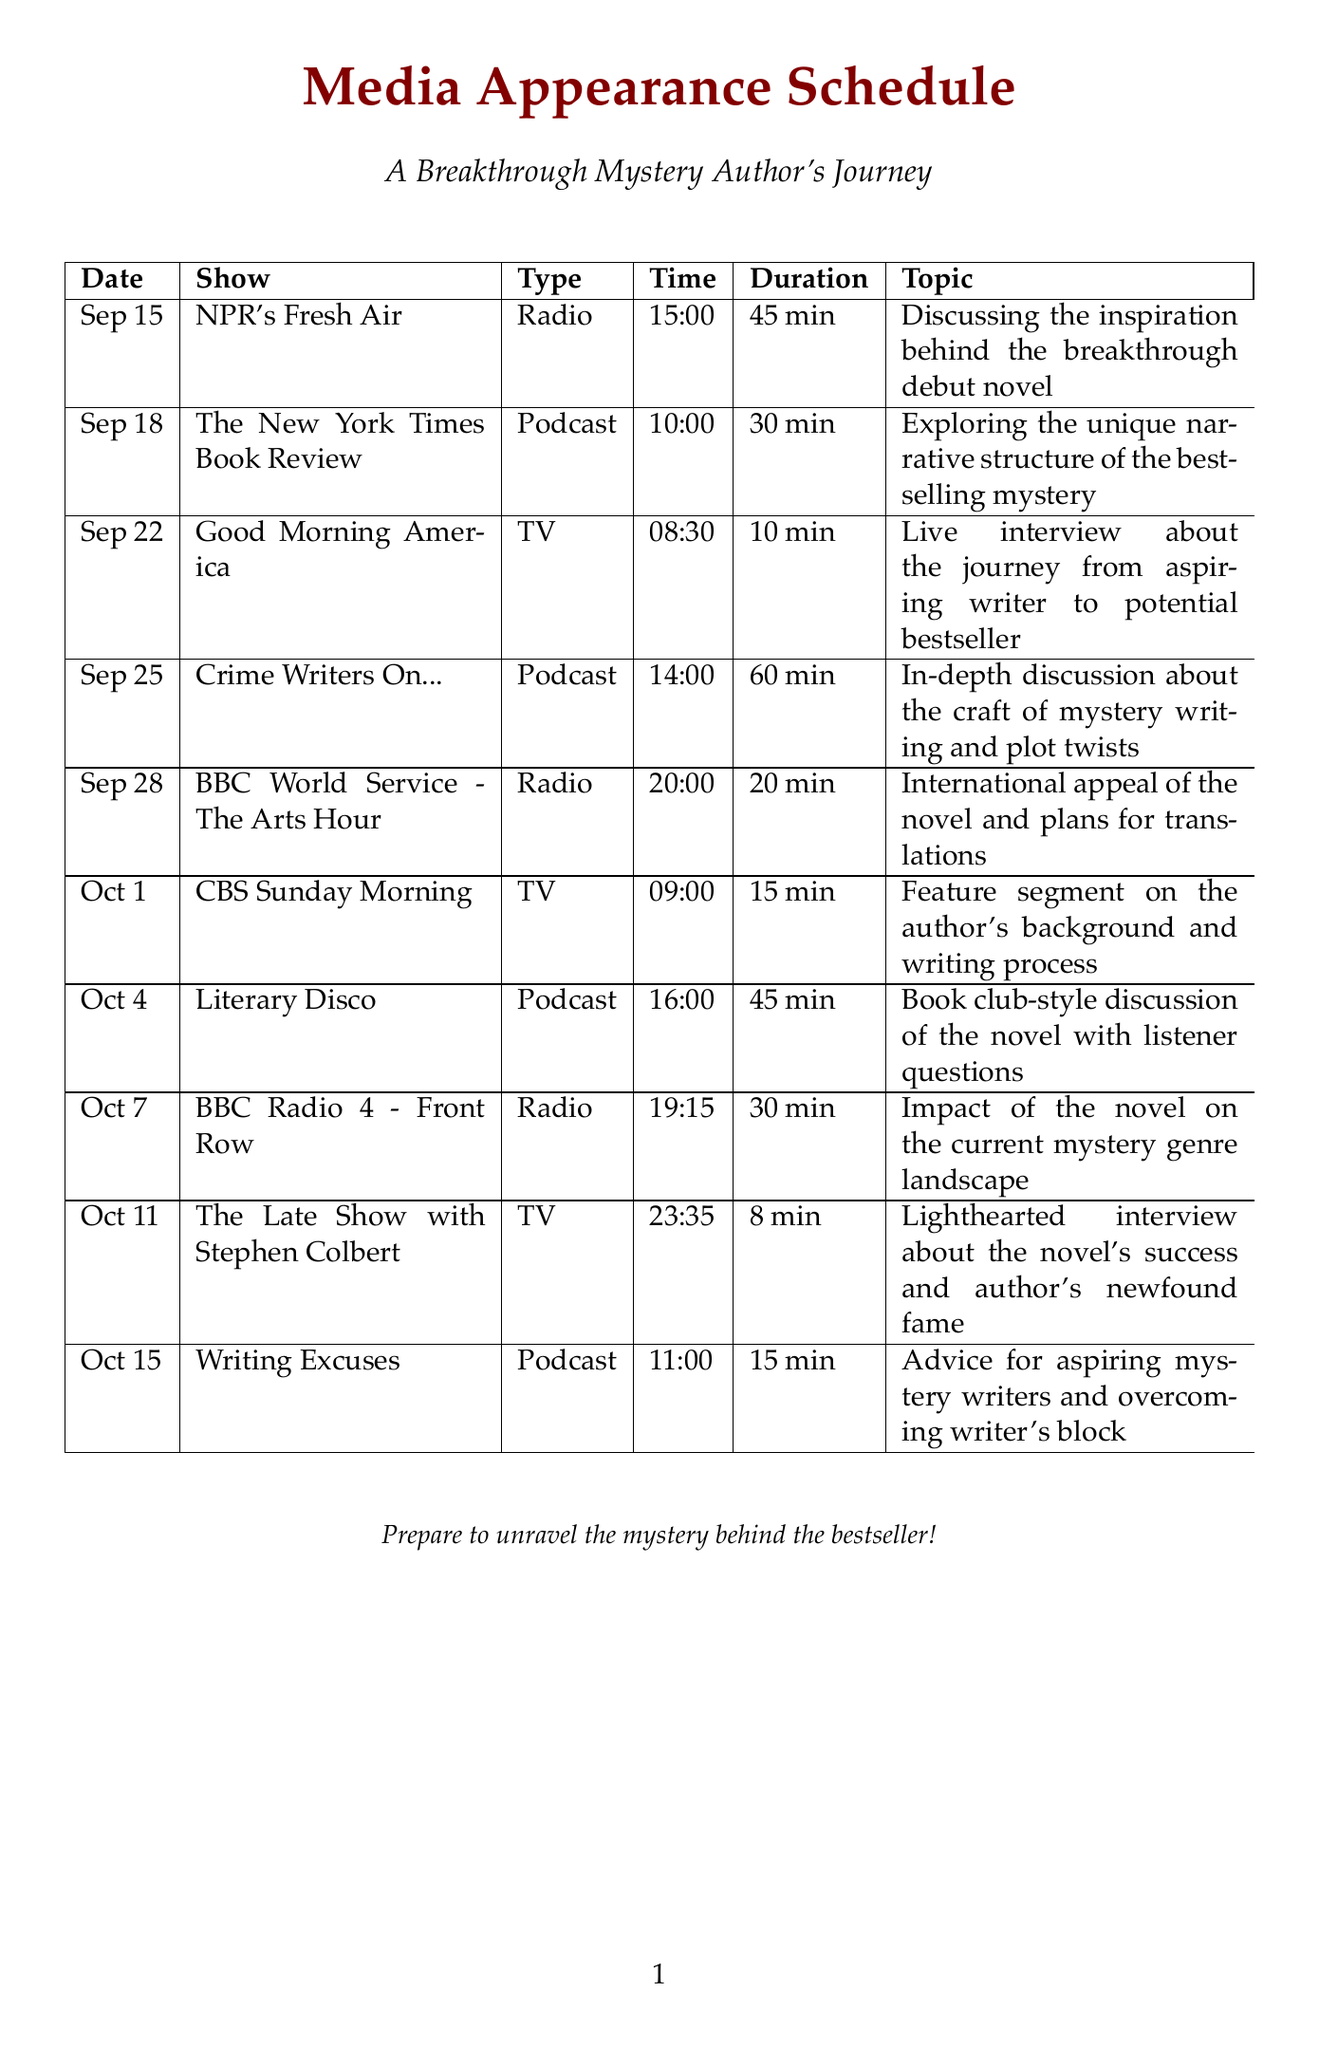what is the date of the first media appearance? The first media appearance is scheduled for September 15, 2023.
Answer: September 15, 2023 what is the name of the podcast show on September 25? The podcast show scheduled for September 25 is "Crime Writers On...".
Answer: Crime Writers On.. how long is the interview on "Good Morning America"? The duration of the interview on "Good Morning America" is 10 minutes.
Answer: 10 minutes who is the host of "NPR's Fresh Air"? The host of "NPR's Fresh Air" is Terry Gross.
Answer: Terry Gross how many media appearances are scheduled for October? There are three media appearances scheduled for October.
Answer: three what is the topic of the interview on "The Late Show with Stephen Colbert"? The topic of the interview is about the novel's success and author's newfound fame.
Answer: Lighthearted interview about the novel's success and author's newfound fame which media appearance focuses on the craft of mystery writing? The media appearance that focuses on the craft of mystery writing is the podcast "Crime Writers On...".
Answer: Crime Writers On.. what time will "BBC Radio 4 - Front Row" air? "BBC Radio 4 - Front Row" will air at 19:15.
Answer: 19:15 who is the host of "Writing Excuses"? The host of "Writing Excuses" is Brandon Sanderson.
Answer: Brandon Sanderson 